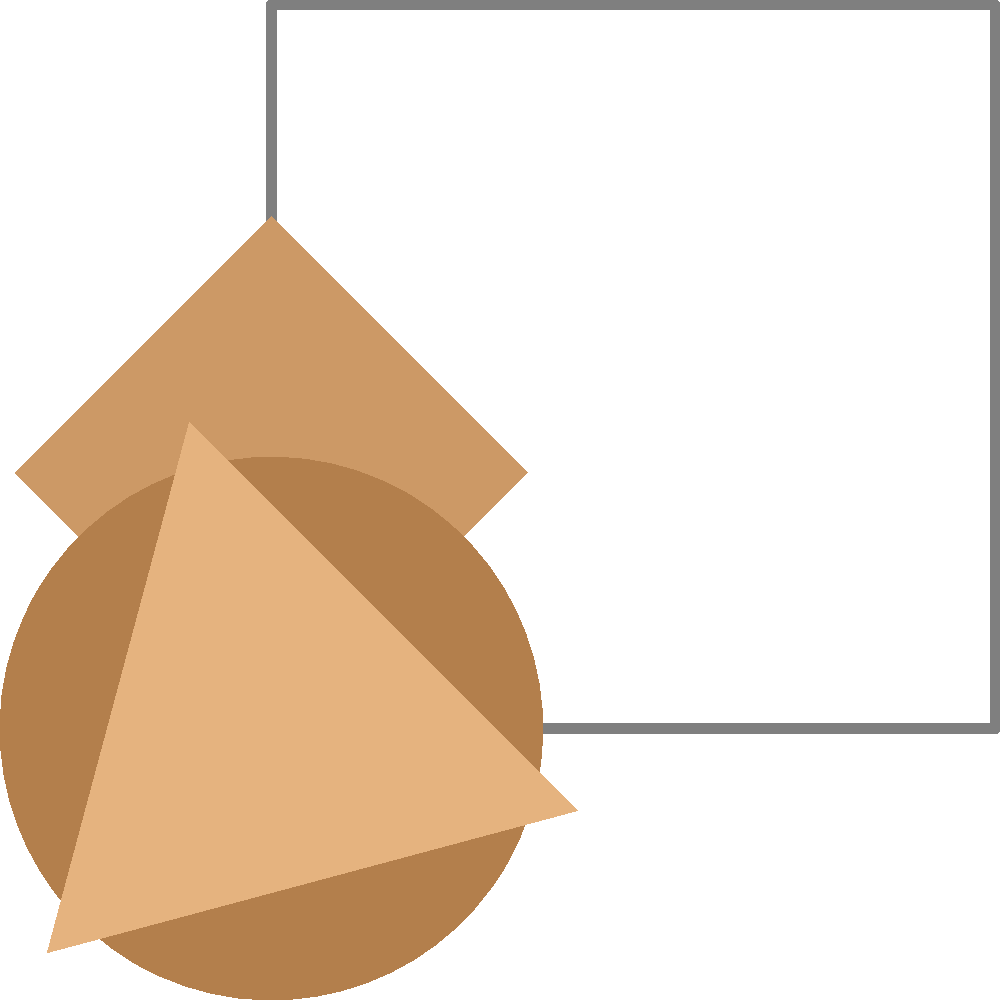In the reconstruction of a human cranium, three skull fragments (A, B, and C) have been identified. Based on their shapes and sizes, which fragment is most likely to fit into the upper right quadrant of the skull outline? To determine which fragment is most likely to fit into the upper right quadrant of the skull outline, we need to analyze the shape, size, and orientation of each fragment:

1. Fragment A: This is a square-shaped fragment rotated at approximately 45 degrees. Its size is relatively large compared to the skull outline.

2. Fragment B: This is a circular fragment, smaller than Fragment A.

3. Fragment C: This is a triangular fragment, similar in size to Fragment B.

4. The upper right quadrant of the skull outline has a curved edge that transitions into a straighter edge towards the top.

Step-by-step analysis:
1. Fragment C (triangular) is unlikely to fit well into the curved upper right quadrant due to its sharp angles.
2. Fragment B (circular) could potentially fit part of the curved edge but wouldn't account for the straighter portion at the top.
3. Fragment A (rotated square) is the largest and its rotation allows it to potentially fit both the curved and straight portions of the upper right quadrant.

Given these observations, Fragment A is the most likely to fit into the upper right quadrant of the skull outline. Its size and shape provide the best match for the contours of that region.
Answer: Fragment A 